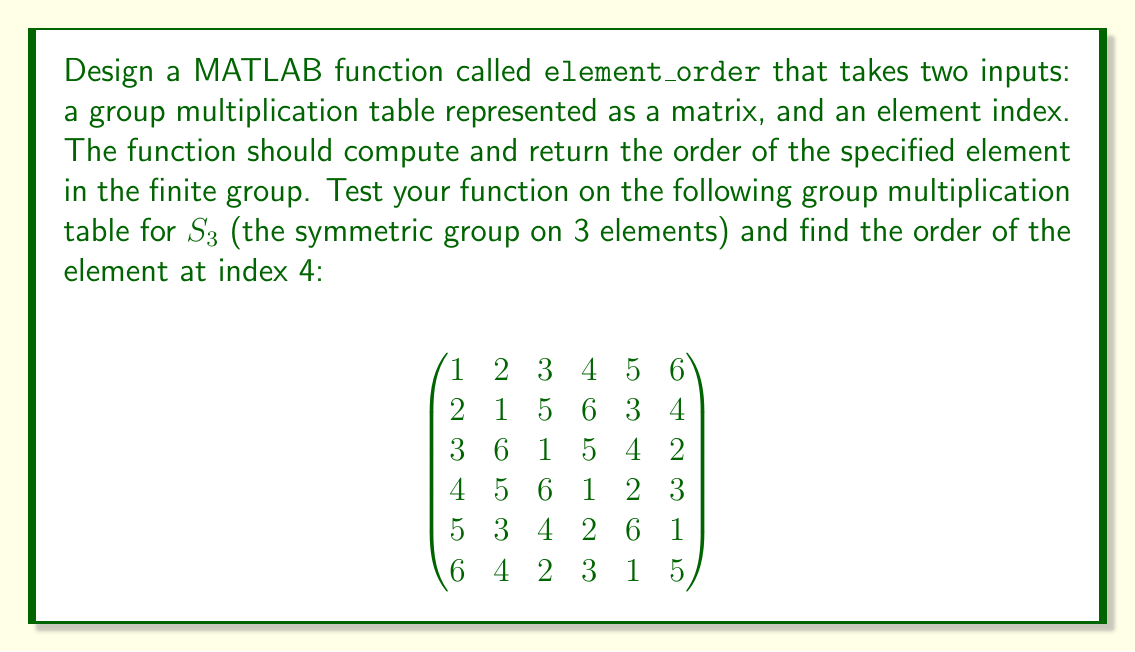What is the answer to this math problem? To solve this problem, we need to create a MATLAB function that computes the order of an element in a finite group. The order of an element $a$ in a group is the smallest positive integer $n$ such that $a^n = e$, where $e$ is the identity element of the group.

Here's a step-by-step explanation of how to design and implement the function:

1. Create a new MATLAB function file named `element_order.m` with the following signature:
   ```matlab
   function order = element_order(group_table, element_index)
   ```

2. Inside the function, first identify the identity element. In a group multiplication table, the identity element is always in the first row and first column:
   ```matlab
   identity = 1;
   ```

3. Initialize the order to 1 and the current element to the input element_index:
   ```matlab
   order = 1;
   current = element_index;
   ```

4. Use a while loop to multiply the current element by the input element until we reach the identity:
   ```matlab
   while current ~= identity
       current = group_table(current, element_index);
       order = order + 1;
   end
   ```

5. Return the computed order.

The complete function should look like this:

```matlab
function order = element_order(group_table, element_index)
    identity = 1;
    order = 1;
    current = element_index;
    
    while current ~= identity
        current = group_table(current, element_index);
        order = order + 1;
    end
end
```

To use this function for the given $S_3$ group and find the order of the element at index 4:

1. Define the group multiplication table:
   ```matlab
   S3 = [1 2 3 4 5 6;
         2 1 5 6 3 4;
         3 6 1 5 4 2;
         4 5 6 1 2 3;
         5 3 4 2 6 1;
         6 4 2 3 1 5];
   ```

2. Call the `element_order` function:
   ```matlab
   result = element_order(S3, 4);
   ```

The function will compute the order of the element at index 4 by repeatedly multiplying it with itself until reaching the identity element. In this case, it will find that $4 \cdot 4 = 1$ (using the group table), so the order is 2.
Answer: The order of the element at index 4 in the given $S_3$ group is 2. 